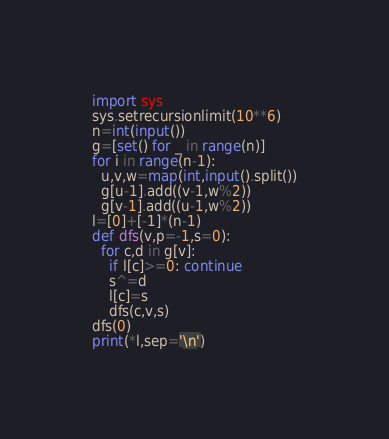Convert code to text. <code><loc_0><loc_0><loc_500><loc_500><_Python_>import sys
sys.setrecursionlimit(10**6)
n=int(input())
g=[set() for _ in range(n)]
for i in range(n-1):
  u,v,w=map(int,input().split())
  g[u-1].add((v-1,w%2))
  g[v-1].add((u-1,w%2))
l=[0]+[-1]*(n-1)
def dfs(v,p=-1,s=0):
  for c,d in g[v]:
    if l[c]>=0: continue
    s^=d
    l[c]=s
    dfs(c,v,s)
dfs(0)
print(*l,sep='\n')</code> 